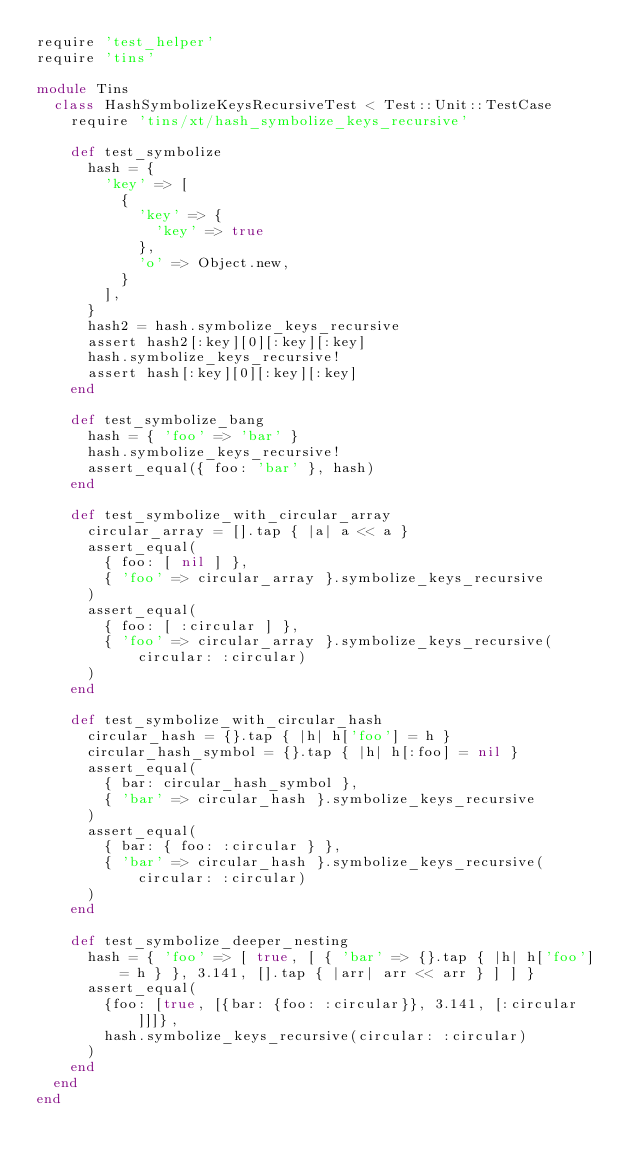Convert code to text. <code><loc_0><loc_0><loc_500><loc_500><_Ruby_>require 'test_helper'
require 'tins'

module Tins
  class HashSymbolizeKeysRecursiveTest < Test::Unit::TestCase
    require 'tins/xt/hash_symbolize_keys_recursive'

    def test_symbolize
      hash = {
        'key' => [
          {
            'key' => {
              'key' => true
            },
            'o' => Object.new,
          }
        ],
      }
      hash2 = hash.symbolize_keys_recursive
      assert hash2[:key][0][:key][:key]
      hash.symbolize_keys_recursive!
      assert hash[:key][0][:key][:key]
    end

    def test_symbolize_bang
      hash = { 'foo' => 'bar' }
      hash.symbolize_keys_recursive!
      assert_equal({ foo: 'bar' }, hash)
    end

    def test_symbolize_with_circular_array
      circular_array = [].tap { |a| a << a }
      assert_equal(
        { foo: [ nil ] },
        { 'foo' => circular_array }.symbolize_keys_recursive
      )
      assert_equal(
        { foo: [ :circular ] },
        { 'foo' => circular_array }.symbolize_keys_recursive(circular: :circular)
      )
    end

    def test_symbolize_with_circular_hash
      circular_hash = {}.tap { |h| h['foo'] = h }
      circular_hash_symbol = {}.tap { |h| h[:foo] = nil }
      assert_equal(
        { bar: circular_hash_symbol },
        { 'bar' => circular_hash }.symbolize_keys_recursive
      )
      assert_equal(
        { bar: { foo: :circular } },
        { 'bar' => circular_hash }.symbolize_keys_recursive(circular: :circular)
      )
    end

    def test_symbolize_deeper_nesting
      hash = { 'foo' => [ true, [ { 'bar' => {}.tap { |h| h['foo'] = h } }, 3.141, [].tap { |arr| arr << arr } ] ] }
      assert_equal(
        {foo: [true, [{bar: {foo: :circular}}, 3.141, [:circular]]]},
        hash.symbolize_keys_recursive(circular: :circular)
      )
    end
  end
end
</code> 